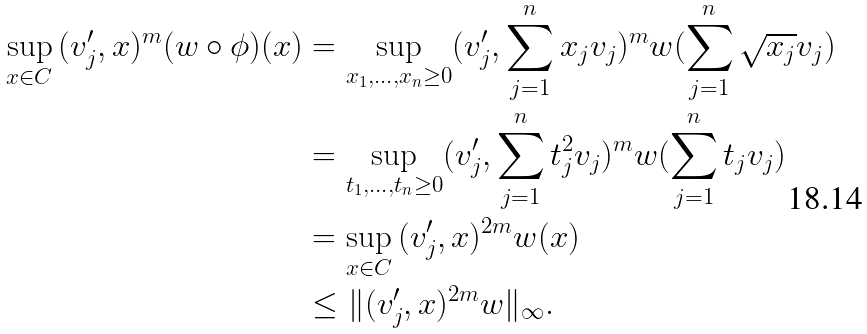Convert formula to latex. <formula><loc_0><loc_0><loc_500><loc_500>\sup _ { x \in C } \, ( v _ { j } ^ { \prime } , x ) ^ { m } ( w \circ \phi ) ( x ) & = \sup _ { x _ { 1 } , \dots , x _ { n } \geq 0 } ( v _ { j } ^ { \prime } , \sum _ { j = 1 } ^ { n } x _ { j } v _ { j } ) ^ { m } w ( \sum _ { j = 1 } ^ { n } \sqrt { x _ { j } } v _ { j } ) \\ & = \sup _ { t _ { 1 } , \dots , t _ { n } \geq 0 } ( v _ { j } ^ { \prime } , \sum _ { j = 1 } ^ { n } t _ { j } ^ { 2 } v _ { j } ) ^ { m } w ( \sum _ { j = 1 } ^ { n } t _ { j } v _ { j } ) \\ & = \sup _ { x \in C } \, ( v _ { j } ^ { \prime } , x ) ^ { 2 m } w ( x ) \\ & \leq \| ( v _ { j } ^ { \prime } , x ) ^ { 2 m } w \| _ { \infty } .</formula> 